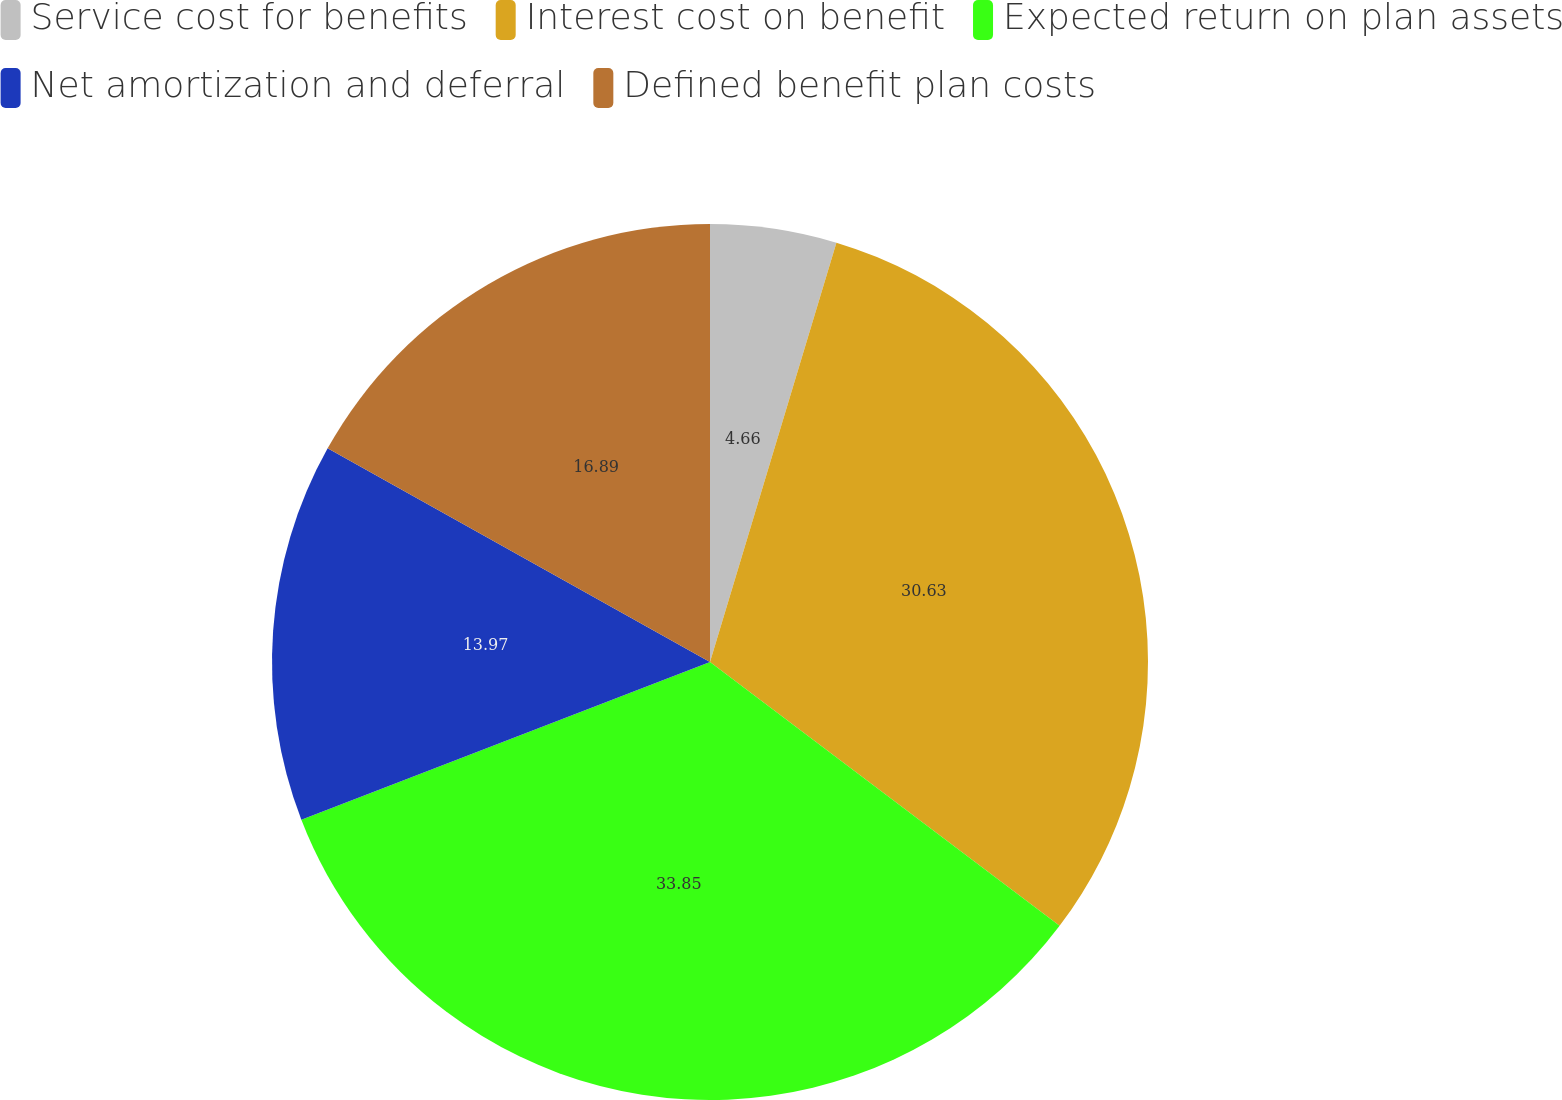<chart> <loc_0><loc_0><loc_500><loc_500><pie_chart><fcel>Service cost for benefits<fcel>Interest cost on benefit<fcel>Expected return on plan assets<fcel>Net amortization and deferral<fcel>Defined benefit plan costs<nl><fcel>4.66%<fcel>30.63%<fcel>33.85%<fcel>13.97%<fcel>16.89%<nl></chart> 